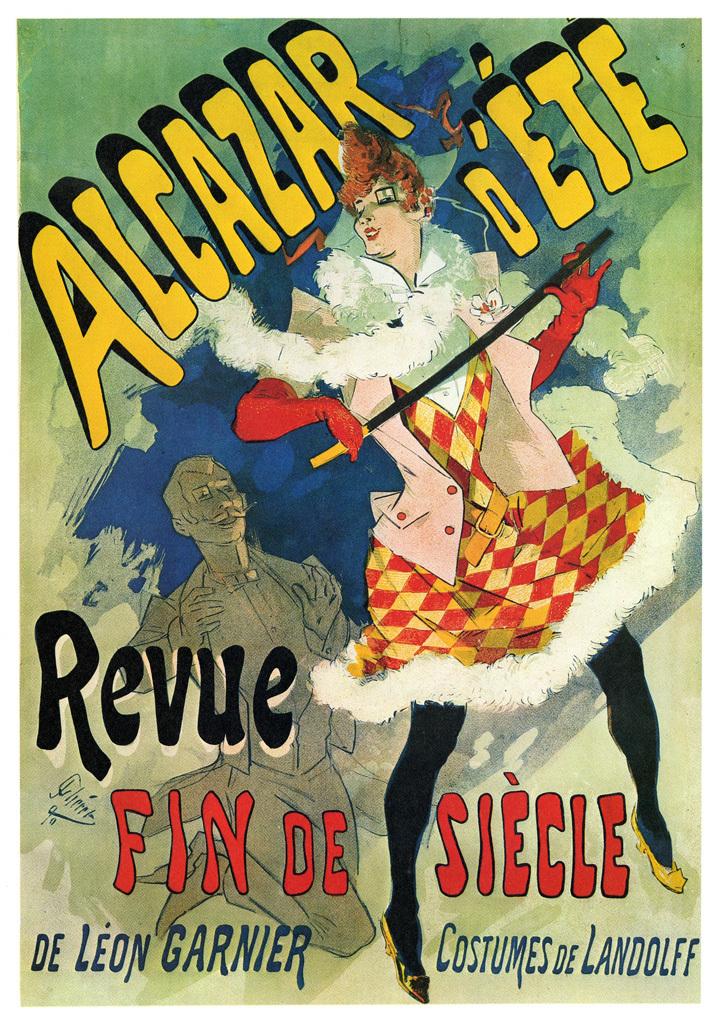What is the ad promoting?
Provide a short and direct response. Revue fin de siecle. What is that name on the bottom left?
Offer a terse response. De leon garnier. 